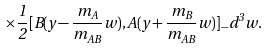Convert formula to latex. <formula><loc_0><loc_0><loc_500><loc_500>\times \frac { 1 } { 2 } [ B ( y - \frac { m _ { A } } { m _ { A B } } w ) , A ( y + \frac { m _ { B } } { m _ { A B } } w ) ] _ { - } d ^ { 3 } w .</formula> 